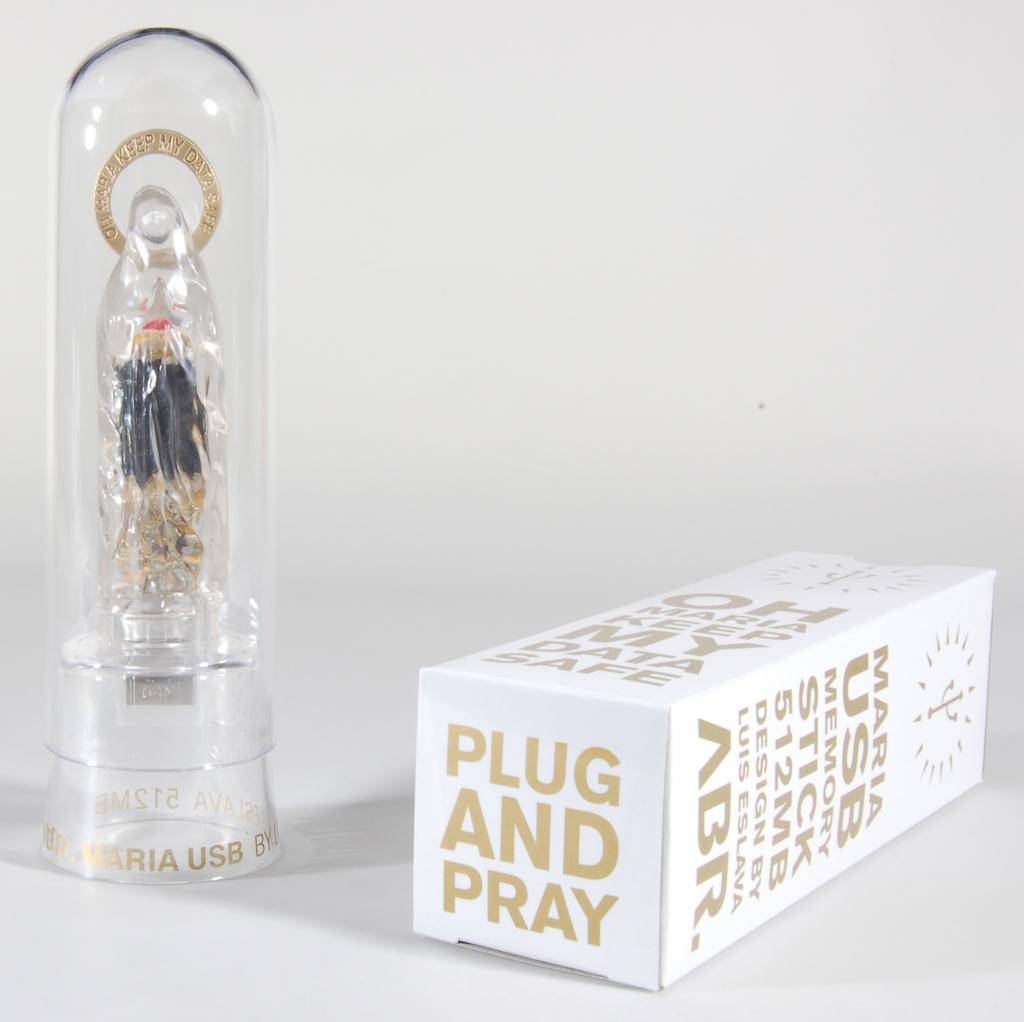<image>
Offer a succinct explanation of the picture presented. a box that is labeled 'maria usb memory stick 512mb design by luis eslava abr.' 